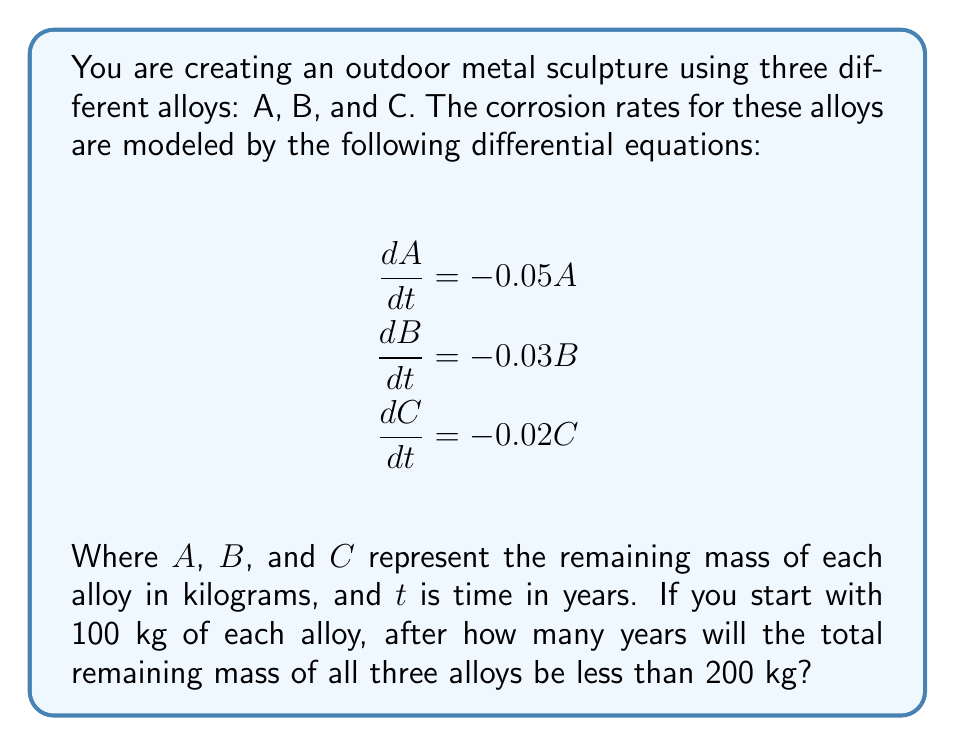Provide a solution to this math problem. To solve this problem, we need to follow these steps:

1) First, we need to solve each differential equation to find the mass of each alloy as a function of time:

   For alloy A: $\frac{dA}{dt} = -0.05A$
   Solving this gives: $A(t) = A_0e^{-0.05t}$, where $A_0$ is the initial mass.

   Similarly, 
   For alloy B: $B(t) = B_0e^{-0.03t}$
   For alloy C: $C(t) = C_0e^{-0.02t}$

2) We know that $A_0 = B_0 = C_0 = 100$ kg. So we can write:

   $A(t) = 100e^{-0.05t}$
   $B(t) = 100e^{-0.03t}$
   $C(t) = 100e^{-0.02t}$

3) The total mass at time $t$ is the sum of these three:

   $Total(t) = 100e^{-0.05t} + 100e^{-0.03t} + 100e^{-0.02t}$

4) We need to find $t$ when $Total(t) < 200$. In other words, we need to solve:

   $100e^{-0.05t} + 100e^{-0.03t} + 100e^{-0.02t} = 200$

5) This equation can't be solved analytically, so we need to use numerical methods. We can use a simple iterative approach:

   Start with $t = 0$ and increase it gradually until the left side becomes less than 200.

6) Using this method (or a more sophisticated numerical method), we find that the solution is approximately $t = 13.86$ years.

7) Since we're asked for the number of years, we round up to the next whole number.
Answer: 14 years 